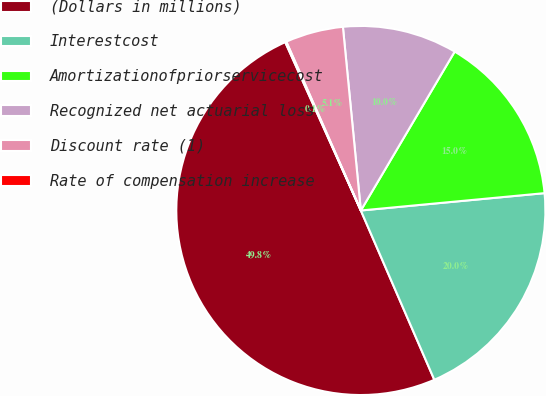<chart> <loc_0><loc_0><loc_500><loc_500><pie_chart><fcel>(Dollars in millions)<fcel>Interestcost<fcel>Amortizationofpriorservicecost<fcel>Recognized net actuarial loss<fcel>Discount rate (1)<fcel>Rate of compensation increase<nl><fcel>49.8%<fcel>19.98%<fcel>15.01%<fcel>10.04%<fcel>5.07%<fcel>0.1%<nl></chart> 